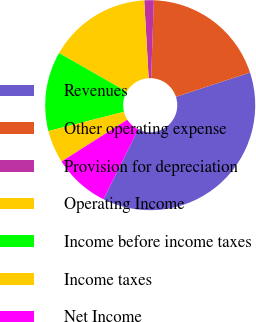Convert chart. <chart><loc_0><loc_0><loc_500><loc_500><pie_chart><fcel>Revenues<fcel>Other operating expense<fcel>Provision for depreciation<fcel>Operating Income<fcel>Income before income taxes<fcel>Income taxes<fcel>Net Income<nl><fcel>37.37%<fcel>19.41%<fcel>1.46%<fcel>15.82%<fcel>12.23%<fcel>5.05%<fcel>8.64%<nl></chart> 